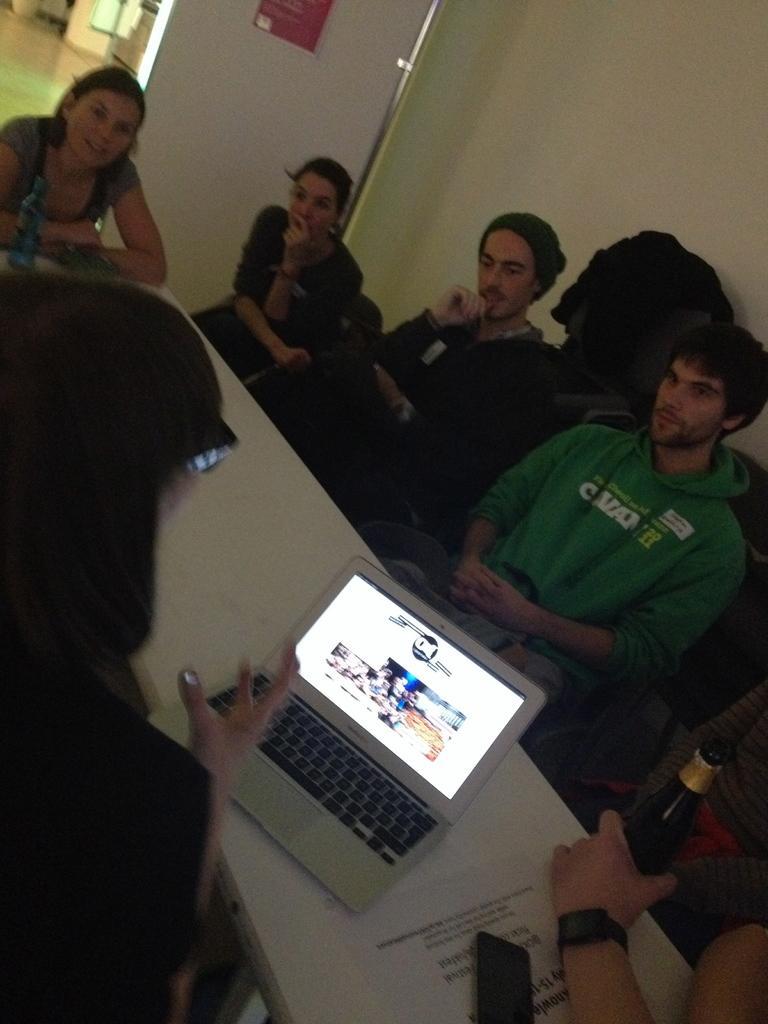Describe this image in one or two sentences. In this image we can see these people are sitting on the chairs on the table. Here we can see laptop opened, mobile phone, paper and a person's hand holding bottle are kept on the table. In the background, we can see the wall and the door. 